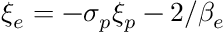<formula> <loc_0><loc_0><loc_500><loc_500>\xi _ { e } = - \sigma _ { p } \xi _ { p } - 2 / \beta _ { e }</formula> 